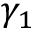Convert formula to latex. <formula><loc_0><loc_0><loc_500><loc_500>\gamma _ { 1 }</formula> 